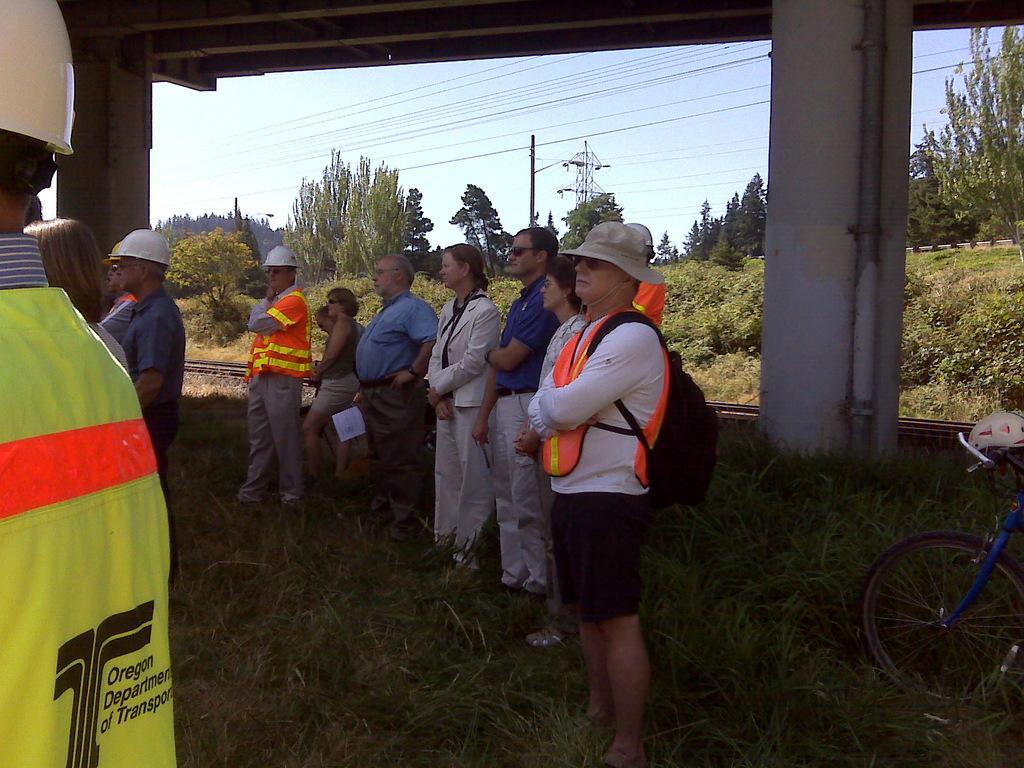In one or two sentences, can you explain what this image depicts? In this image I can see few people are standing. I can see few of them wearing helmets and one man is wearing a cap. Here I can see a cycle and in background I can see number of trees and a tower. 